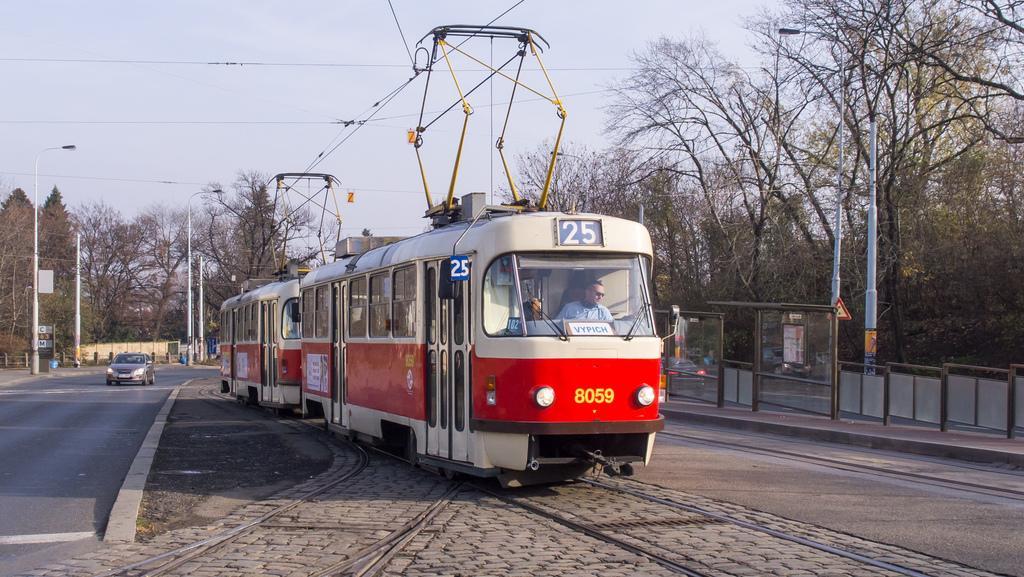Please provide a concise description of this image. In this image, we can see a person in a train. There are a few vehicles. We can see the ground with some objects. There are a few poles, trees, wires, boards and some sign boards. We can see the fence and the sky. 